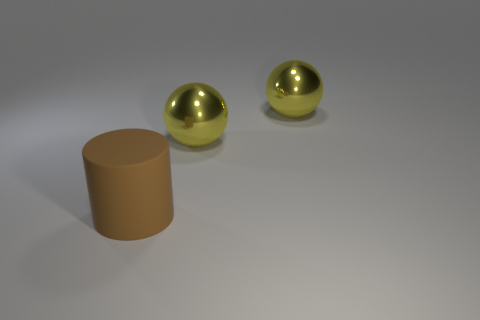Add 1 metallic objects. How many objects exist? 4 Add 1 large blue rubber cubes. How many large blue rubber cubes exist? 1 Subtract 0 green cylinders. How many objects are left? 3 Subtract all spheres. How many objects are left? 1 Subtract all gray cylinders. Subtract all green spheres. How many cylinders are left? 1 Subtract all purple blocks. How many gray balls are left? 0 Subtract all big yellow metallic spheres. Subtract all rubber objects. How many objects are left? 0 Add 3 big rubber cylinders. How many big rubber cylinders are left? 4 